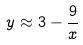<formula> <loc_0><loc_0><loc_500><loc_500>y \approx 3 - \frac { 9 } { x }</formula> 